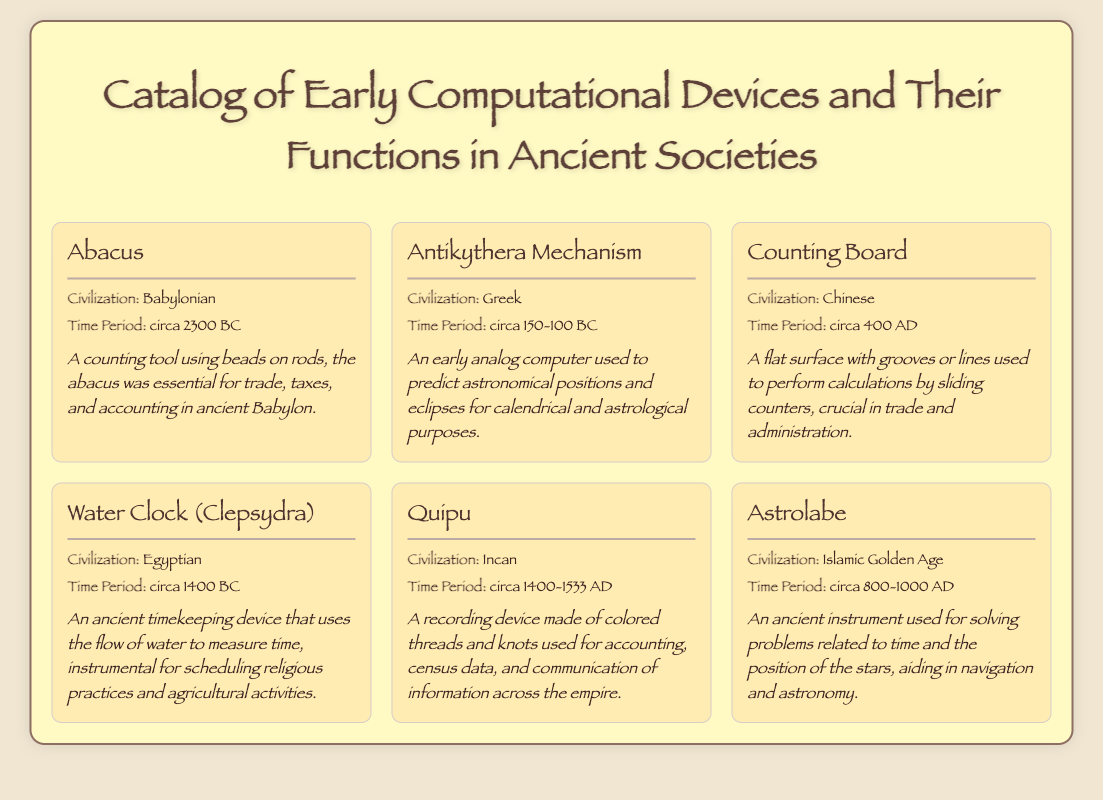What civilization created the Abacus? The Abacus was created by the Babylonian civilization.
Answer: Babylonian What time period does the Antikythera Mechanism belong to? The Antikythera Mechanism belongs to the time period circa 150-100 BC.
Answer: circa 150-100 BC What device was crucial for trade and administration in China? The device crucial for trade and administration in China was the Counting Board.
Answer: Counting Board What does the Water Clock measure? The Water Clock measures time using the flow of water.
Answer: Time What material is the Quipu made of? The Quipu is made of colored threads and knots.
Answer: Colored threads and knots How does the Astrolabe assist ancient societies? The Astrolabe assists by solving problems related to time and the position of the stars.
Answer: Time and position of the stars Which device was used for scheduling religious practices in Egypt? The device used for scheduling religious practices in Egypt was the Water Clock.
Answer: Water Clock Which civilization is associated with the invention of the Astrolabe? The Astrolabe is associated with the Islamic Golden Age civilization.
Answer: Islamic Golden Age What is the primary use of the Antikythera Mechanism? The primary use of the Antikythera Mechanism is to predict astronomical positions.
Answer: Predict astronomical positions 